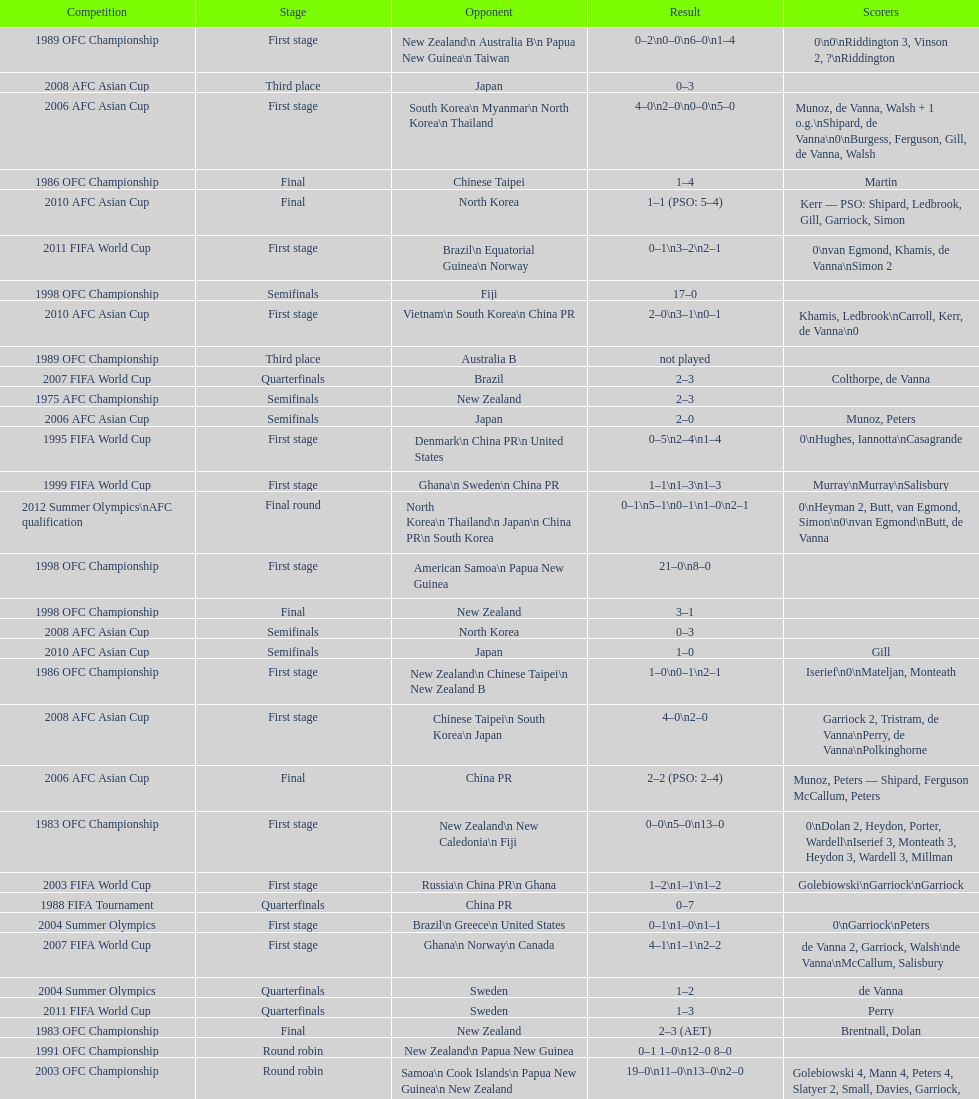How many points were scored in the final round of the 2012 summer olympics afc qualification? 12. 